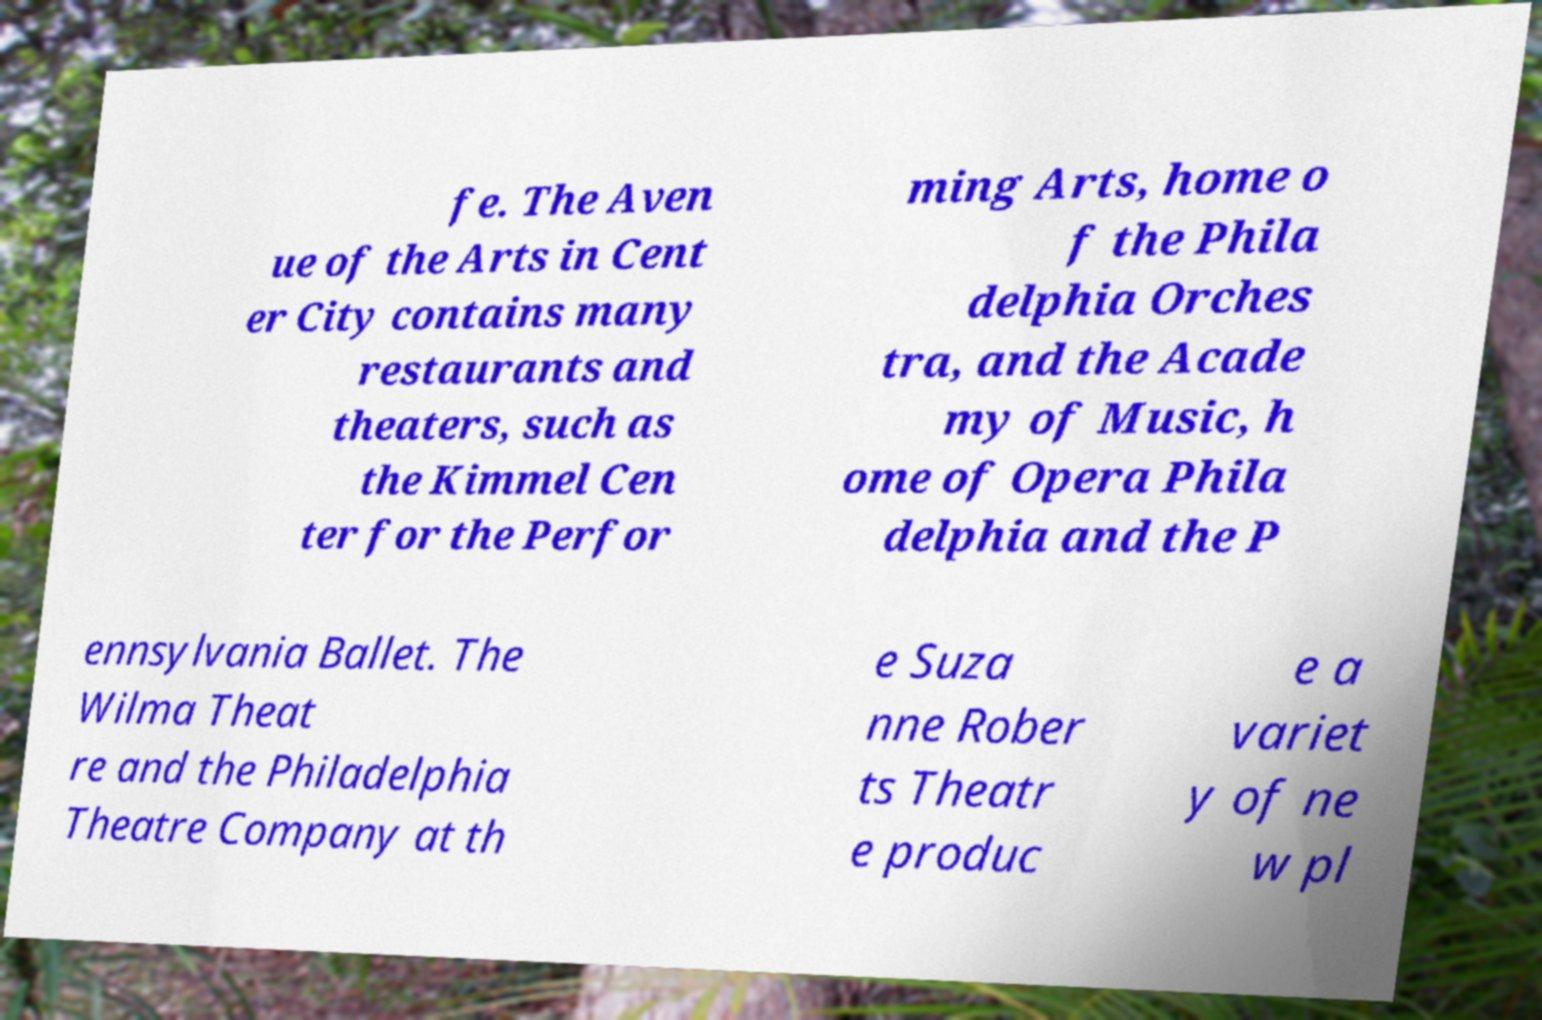Could you extract and type out the text from this image? fe. The Aven ue of the Arts in Cent er City contains many restaurants and theaters, such as the Kimmel Cen ter for the Perfor ming Arts, home o f the Phila delphia Orches tra, and the Acade my of Music, h ome of Opera Phila delphia and the P ennsylvania Ballet. The Wilma Theat re and the Philadelphia Theatre Company at th e Suza nne Rober ts Theatr e produc e a variet y of ne w pl 